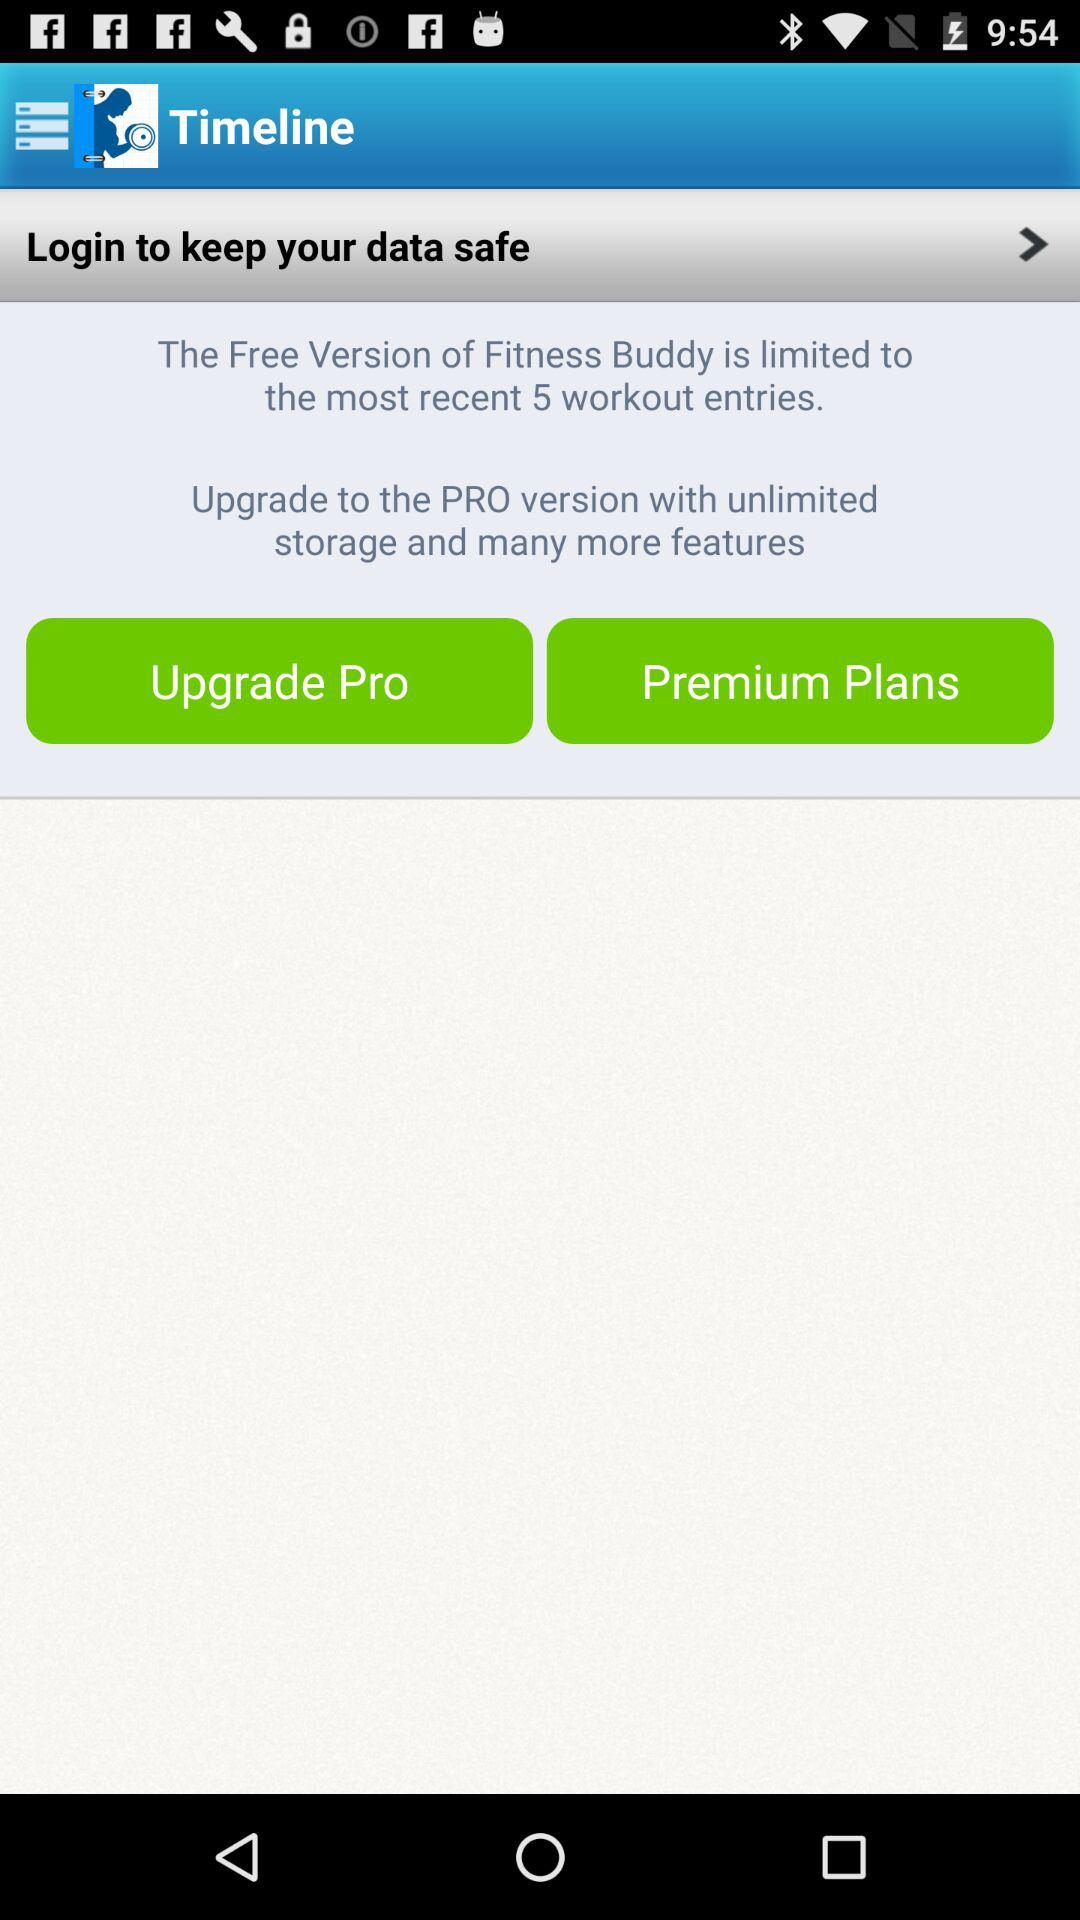How many workout entries are allowed in the Free Version of Fitness Buddy?
Answer the question using a single word or phrase. 5 